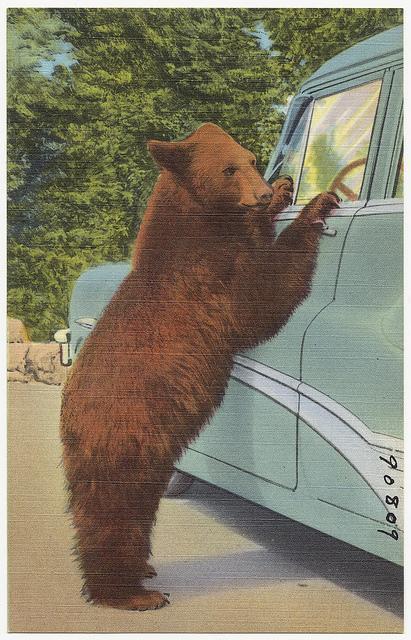How many bears are there?
Give a very brief answer. 1. How many cars can you see?
Give a very brief answer. 1. How many people can be seen?
Give a very brief answer. 0. 